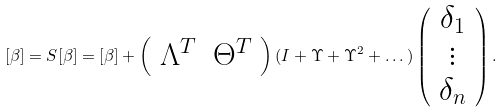Convert formula to latex. <formula><loc_0><loc_0><loc_500><loc_500>[ \beta ] = S [ \beta ] = [ \beta ] + \left ( \begin{array} { c c } \Lambda ^ { T } & \Theta ^ { T } \end{array} \right ) ( I + \Upsilon + \Upsilon ^ { 2 } + \dots ) \left ( \begin{array} { c } \delta _ { 1 } \\ \vdots \\ \delta _ { n } \end{array} \right ) .</formula> 